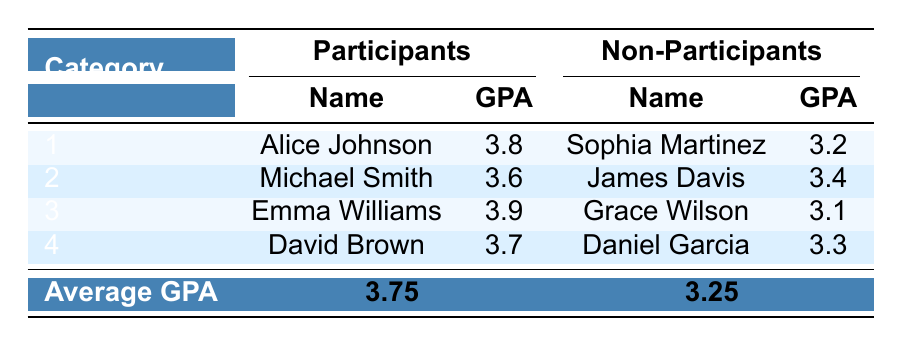What is the GPA of Emma Williams? Emma Williams is listed under the participants in the table, and her GPA is clearly stated as 3.9.
Answer: 3.9 Who has the highest GPA among the non-participants? Among the non-participants, the table shows Daniel Garcia with a GPA of 3.3 which is higher than the others: Sophia Martinez (3.2), James Davis (3.4), and Grace Wilson (3.1).
Answer: Daniel Garcia What is the average GPA of students who participate in extracurricular activities? To find the average GPA of participants, we sum their GPAs: 3.8 + 3.6 + 3.9 + 3.7 = 15.0, and there are 4 students, so the average is 15.0 / 4 = 3.75.
Answer: 3.75 Is it true that all students who engage in extracurricular activities have a higher GPA than the non-participants? When comparing the highest GPA of participants (3.9 for Emma Williams) with the highest GPA of non-participants (3.4 for James Davis), we see that at least one participant has a higher GPA than any non-participant. Therefore, it is not true that all participants have higher GPAs since some non-participants exceed the GPAs of some participants.
Answer: No What is the total GPA of all participants combined? To find the total GPA of participants, we add their GPAs together: 3.8 + 3.6 + 3.9 + 3.7 = 15.0.
Answer: 15.0 Which major has the lowest GPA among the participants? The table indicates that among the participants, the person with the lowest GPA is Michael Smith (3.6) majoring in Biology compared to other participants: Alice Johnson (3.8), Emma Williams (3.9), and David Brown (3.7).
Answer: Biology What is the difference in average GPA between participants and non-participants? To find the difference, subtract the average GPA of non-participants (3.25) from the average GPA of participants (3.75): 3.75 - 3.25 = 0.50.
Answer: 0.50 How many students have a GPA higher than 3.5 among the participants? The participants with GPAs higher than 3.5 are Alice Johnson (3.8), Michael Smith (3.6), and Emma Williams (3.9), totaling three students.
Answer: 3 